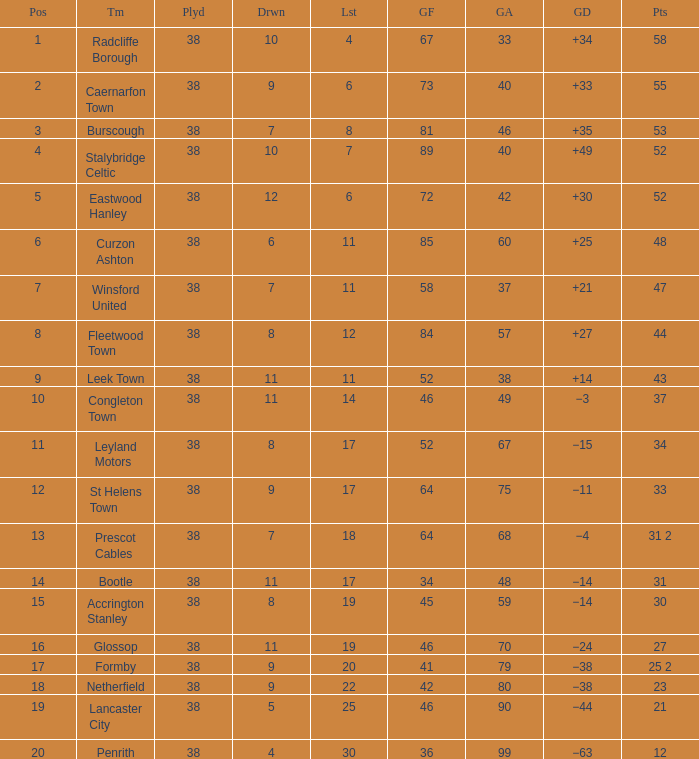WHAT POINTS 1 HAD A 22 LOST? 23.0. 